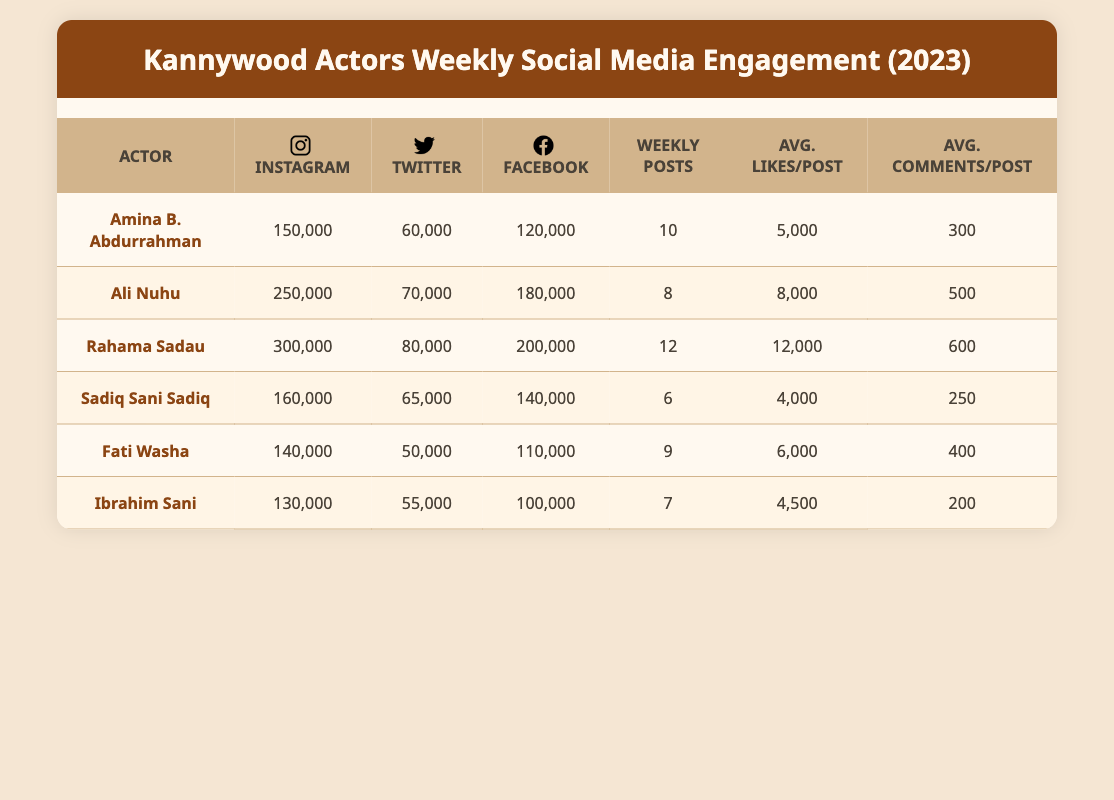What are the Instagram followers for Rahama Sadau? The table shows that Rahama Sadau has 300,000 Instagram followers.
Answer: 300,000 What is the average number of likes per post for Sadiq Sani Sadiq? The table indicates that Sadiq Sani Sadiq receives an average of 4,000 likes per post.
Answer: 4,000 Which actor has the most Facebook likes, and how many do they have? By comparing the Facebook likes for all actors listed, Rahama Sadau has the most with a total of 200,000 likes.
Answer: Rahama Sadau, 200,000 What is the total number of weekly posts made by all actors combined? To find the total, sum the weekly posts: 10 (Amina) + 8 (Ali) + 12 (Rahama) + 6 (Sadiq) + 9 (Fati) + 7 (Ibrahim) = 52 weekly posts in total.
Answer: 52 Does Ali Nuhu have more Twitter followers than Sadiq Sani Sadiq? Comparing their Twitter followers, Ali Nuhu has 70,000 while Sadiq Sani Sadiq has 65,000, thus Ali Nuhu does have more.
Answer: Yes Which actor has the highest average comments per post, and how many do they have? By comparing average comments: Rahama Sadau has the highest with 600 comments per post.
Answer: Rahama Sadau, 600 How many fewer Facebook likes does Fati Washa have compared to Rahama Sadau? To find the difference, subtract Fati Washa's Facebook likes from Rahama Sadau's: 200,000 (Rahama) - 110,000 (Fati) = 90,000 fewer likes.
Answer: 90,000 Is the average likes per post for Amina B. Abdurrahman greater than 5,000? The table shows that Amina has an average of 5,000 likes per post, which means her average is not greater.
Answer: No Who has the fewest total social media followers across Instagram, Twitter, and Facebook? Calculate total followers: Ibrahim Sani has 130,000 (Instagram) + 55,000 (Twitter) + 100,000 (Facebook) = 285,000 total, which is less than others.
Answer: Ibrahim Sani, 285,000 